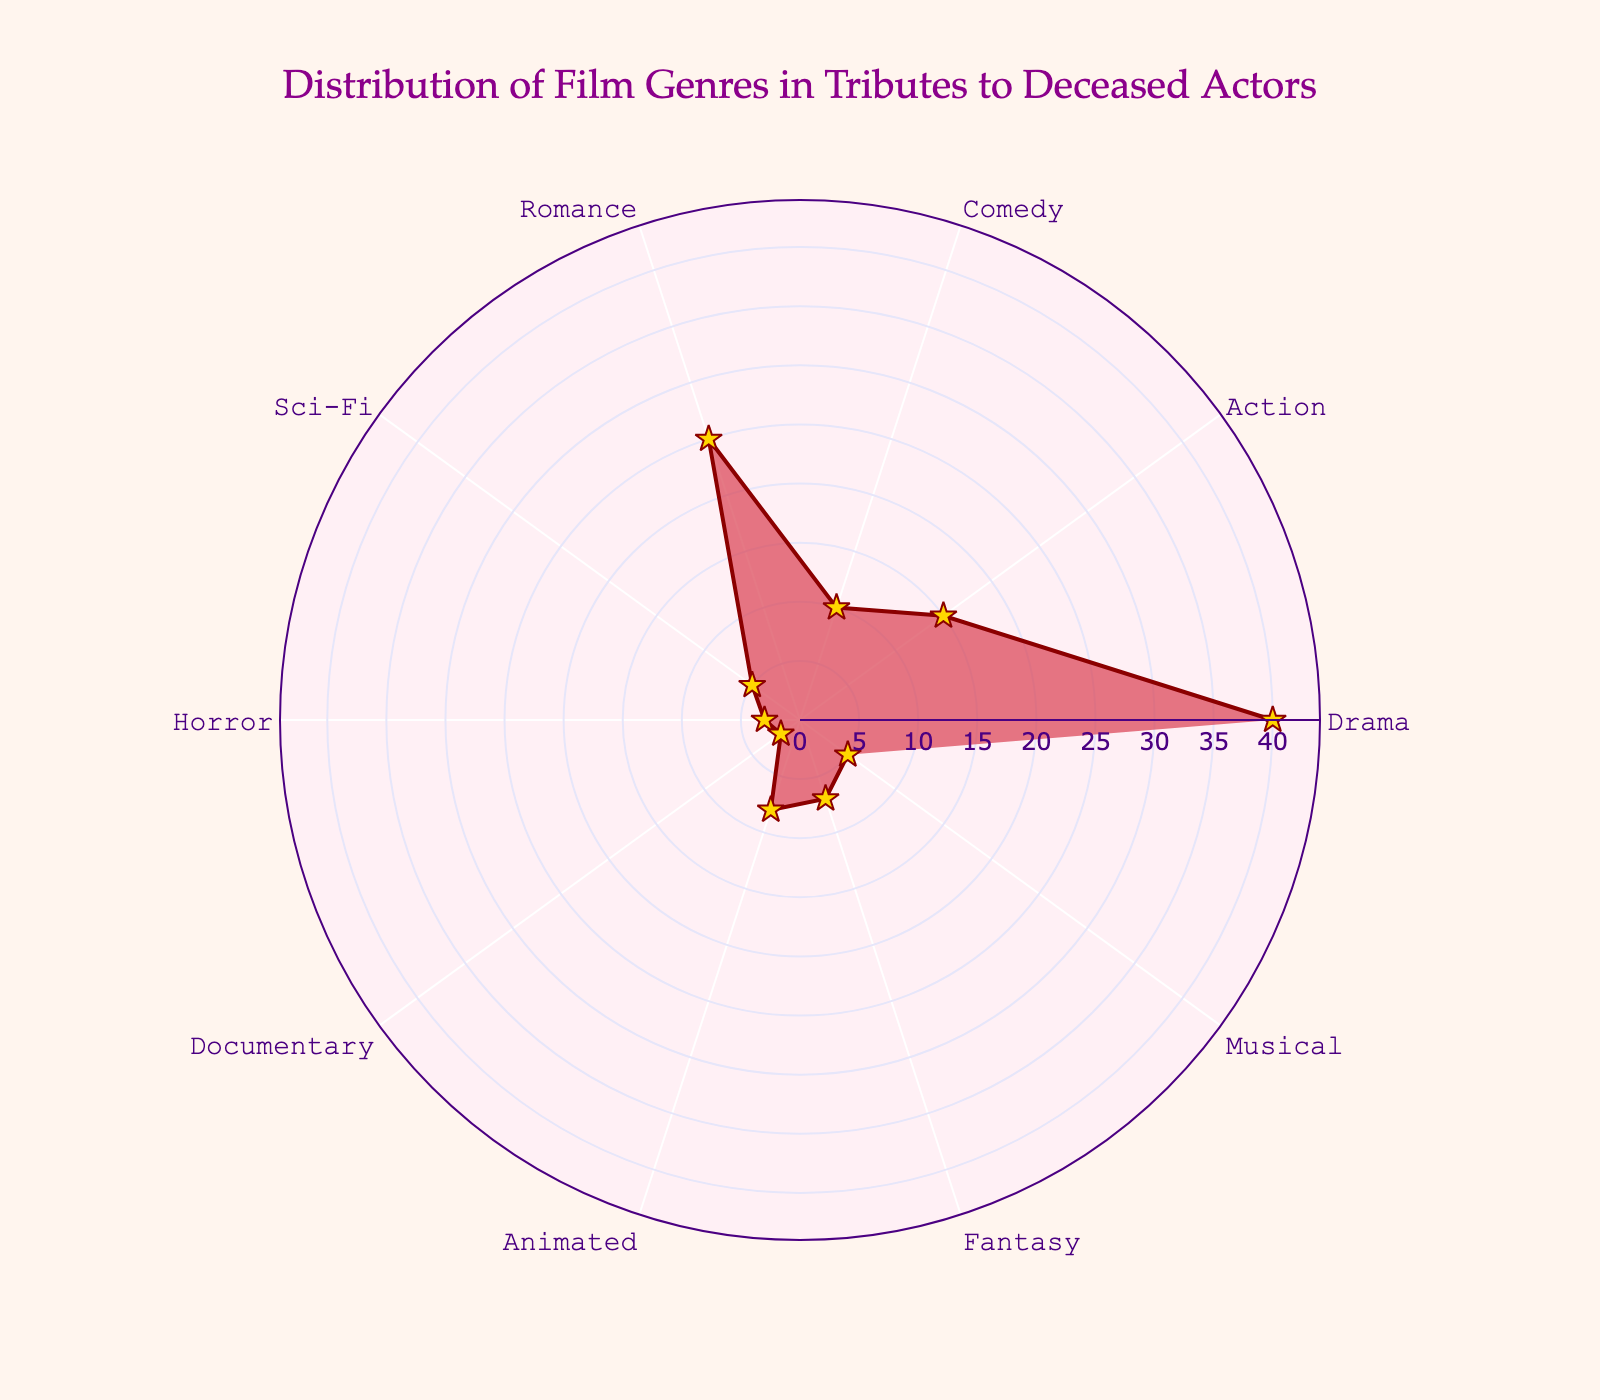What's the title of the chart? The title is displayed at the top of the figure in a prominent font to describe the main subject of the chart.
Answer: Distribution of Film Genres in Tributes to Deceased Actors Which film genre has the highest count in the chart? By observing the length of the colored segments, the longest segment represents the film genre with the highest count.
Answer: Drama What's the count difference between Drama and Sci-Fi? The Drama segment has a count of 40, and the Sci-Fi segment has a count of 5. Subtracting these values: 40 - 5 = 35.
Answer: 35 Which genres have counts greater than 20? By examining segments with radial positions greater than 20, these genres are clearly identified.
Answer: Drama (40) and Romance (25) How many genres have a count of 5 or less? Count the number of segments with radial positions at 5 or below: Sci-Fi (5), Horror (3), Documentary (2), and Musical (5).
Answer: 4 genres What is the combined count of Action and Comedy film genres? The counts for Action and Comedy are 15 and 10, respectively. Adding these: 15 + 10 = 25.
Answer: 25 How does the count of Animated compare to that of Fantasy? Observe the radial positions for Animated (8) and Fantasy (7). Animated has a slightly higher count.
Answer: Animated has a higher count What is the average count of genres with more than 10? Identify genres with counts of more than 10: Drama (40), Action (15), Romance (25). Calculate the average: (40 + 15 + 25) / 3 = 80 / 3 ≈ 26.67.
Answer: 26.67 Which film genre has the second lowest count? The lowest count is Documentary (2). The second lowest is Horror (3).
Answer: Horror What's the proportion of Comedy count relative to the total count? Sum all genre counts (40 + 15 + 10 + 25 + 5 + 3 + 2 + 8 + 7 + 5 = 120). Calculate the proportion for Comedy: 10 / 120 = 1/12 ≈ 0.0833.
Answer: 0.0833 (or 8.33%) 